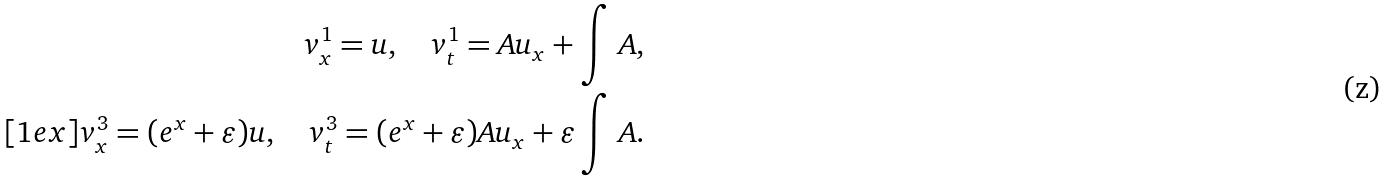Convert formula to latex. <formula><loc_0><loc_0><loc_500><loc_500>v ^ { 1 } _ { x } = u , \quad v ^ { 1 } _ { t } = A u _ { x } + \int \, A , \\ [ 1 e x ] v ^ { 3 } _ { x } = ( e ^ { x } + \varepsilon ) u , \quad v ^ { 3 } _ { t } = ( e ^ { x } + \varepsilon ) A u _ { x } + \varepsilon \int \, A .</formula> 